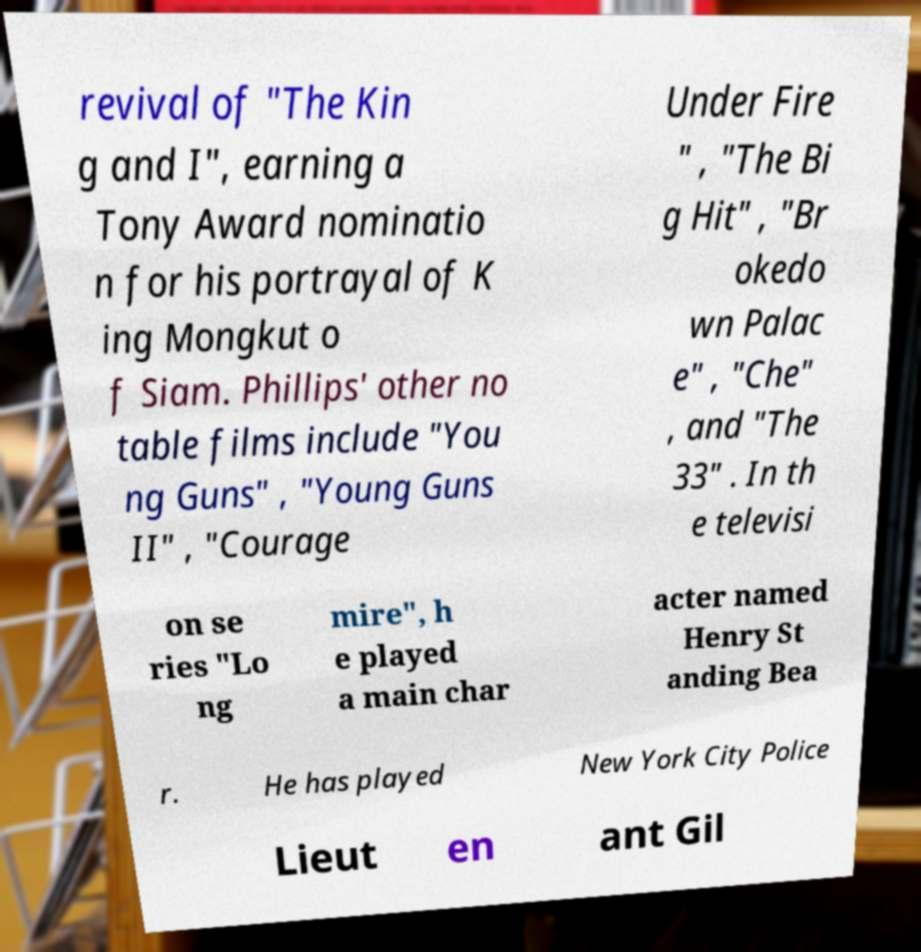For documentation purposes, I need the text within this image transcribed. Could you provide that? revival of "The Kin g and I", earning a Tony Award nominatio n for his portrayal of K ing Mongkut o f Siam. Phillips' other no table films include "You ng Guns" , "Young Guns II" , "Courage Under Fire " , "The Bi g Hit" , "Br okedo wn Palac e" , "Che" , and "The 33" . In th e televisi on se ries "Lo ng mire", h e played a main char acter named Henry St anding Bea r. He has played New York City Police Lieut en ant Gil 